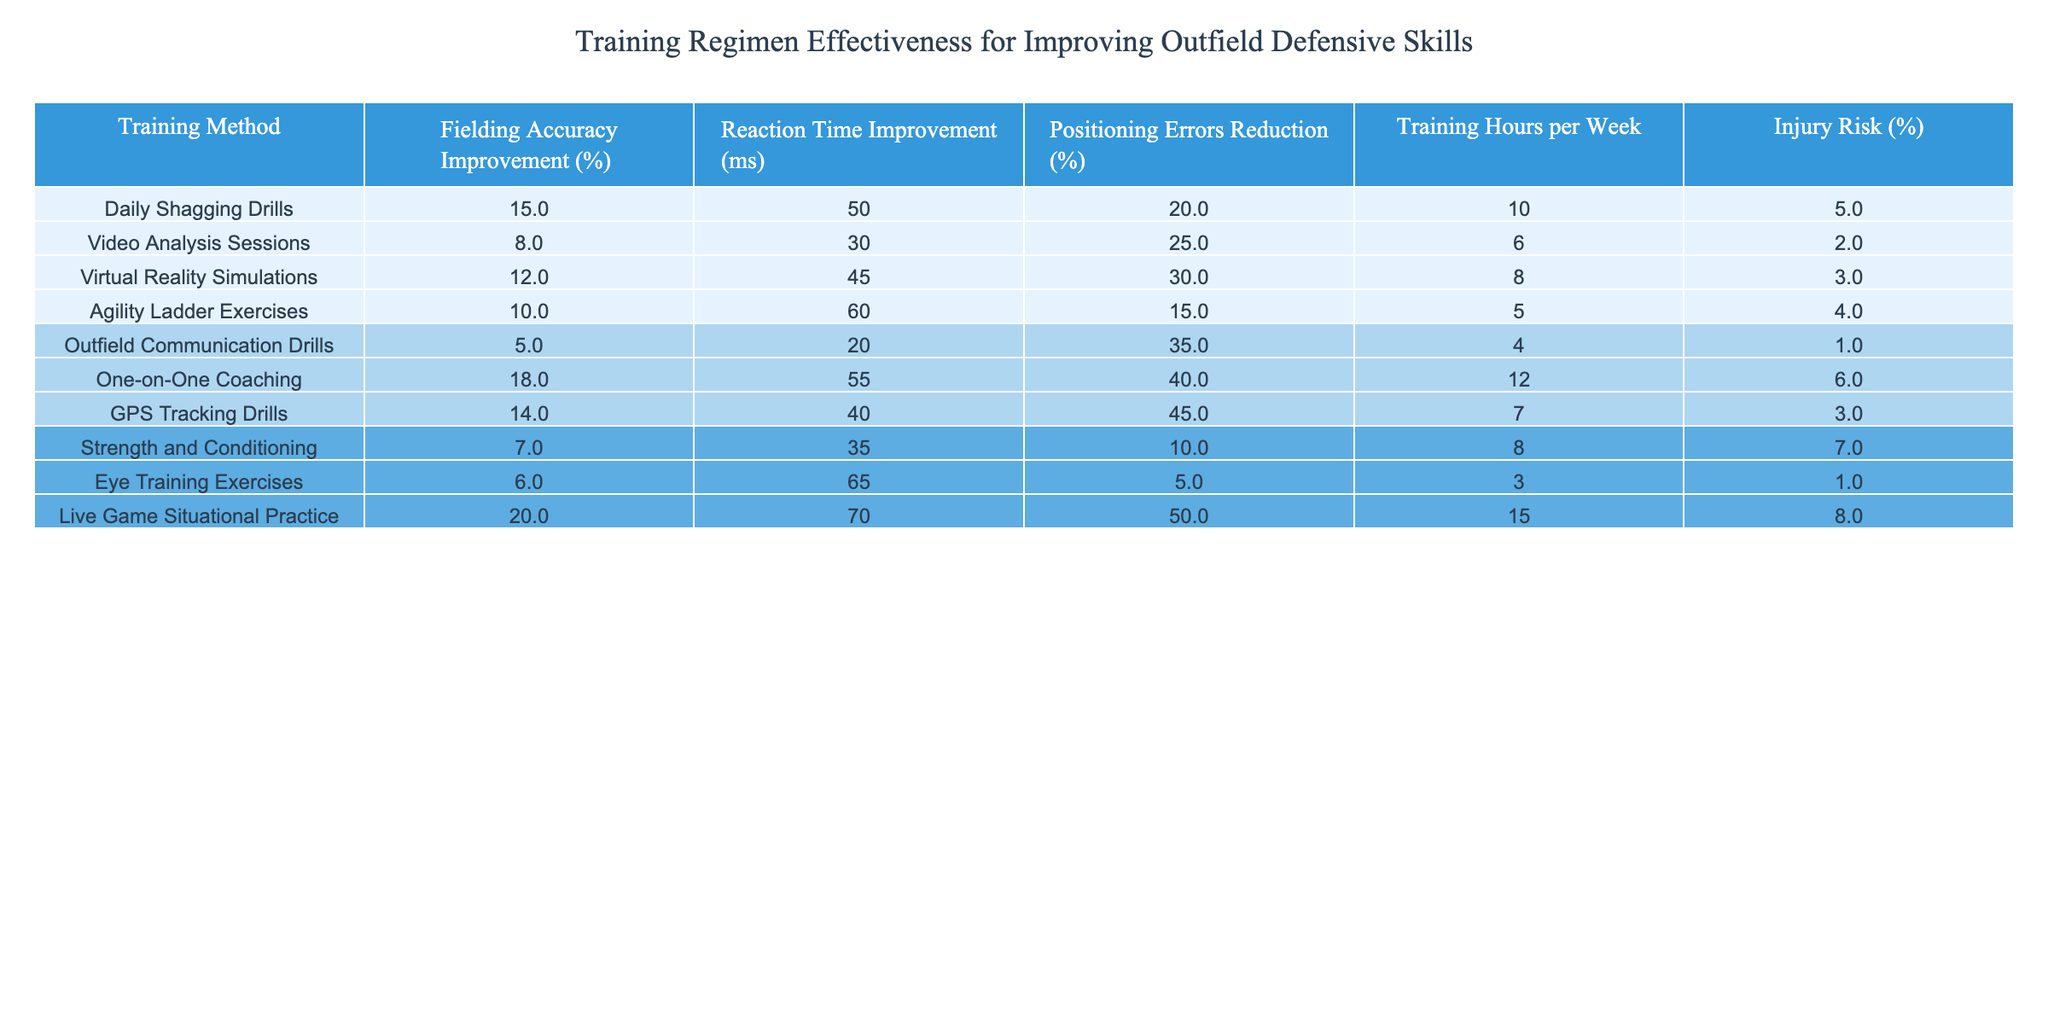What is the highest percentage of fielding accuracy improvement achieved by any training method? The training method with the highest fielding accuracy improvement is "Live Game Situational Practice," which has an improvement of 20%.
Answer: 20% Which training method has the lowest injury risk? The training method with the lowest injury risk is "Outfield Communication Drills," which has an injury risk of 1%.
Answer: 1% What is the average reduction in positioning errors across all training methods? To find the average reduction in positioning errors, sum the percentages (20 + 25 + 30 + 15 + 35 + 40 + 45 + 10 + 5 + 50 = 355) and divide by the number of methods (10): 355 / 10 = 35.5%.
Answer: 35.5% Which method is the most time-consuming based on training hours per week? The training method that requires the most training hours per week is "Live Game Situational Practice," which requires 15 hours.
Answer: 15 hours Is "Video Analysis Sessions" more effective than "Eye Training Exercises" for improving fielding accuracy? "Video Analysis Sessions" have an improvement of 8%, while "Eye Training Exercises" have an improvement of 6%, so "Video Analysis Sessions" is indeed more effective for that metric.
Answer: Yes How many training methods result in over 40% reduction in positioning errors? The training methods that result in over 40% reduction are "One-on-One Coaching" (40%), "GPS Tracking Drills" (45%), and "Live Game Situational Practice" (50%). That's a total of 3 methods.
Answer: 3 What is the difference in reaction time improvement between "Daily Shagging Drills" and "Agility Ladder Exercises"? "Daily Shagging Drills" improves reaction time by 50 ms, while "Agility Ladder Exercises" improves it by 60 ms, so the difference is 60 - 50 = 10 ms.
Answer: 10 ms Which training method has the highest improvement in reaction time and how much is it? "Live Game Situational Practice" shows the highest improvement in reaction time with 70 ms.
Answer: 70 ms If a player practices "One-on-One Coaching" for 12 hours and "Virtual Reality Simulations" for 8 hours, what is their total training time per week? The total training time is 12 hours (One-on-One Coaching) + 8 hours (Virtual Reality Simulations) = 20 hours per week.
Answer: 20 hours Considering fielding accuracy improvement, which method should a rookie outfielder prioritize for training? The method with the highest fielding accuracy improvement is "Live Game Situational Practice," which would be the best choice to prioritize for training.
Answer: "Live Game Situational Practice" 